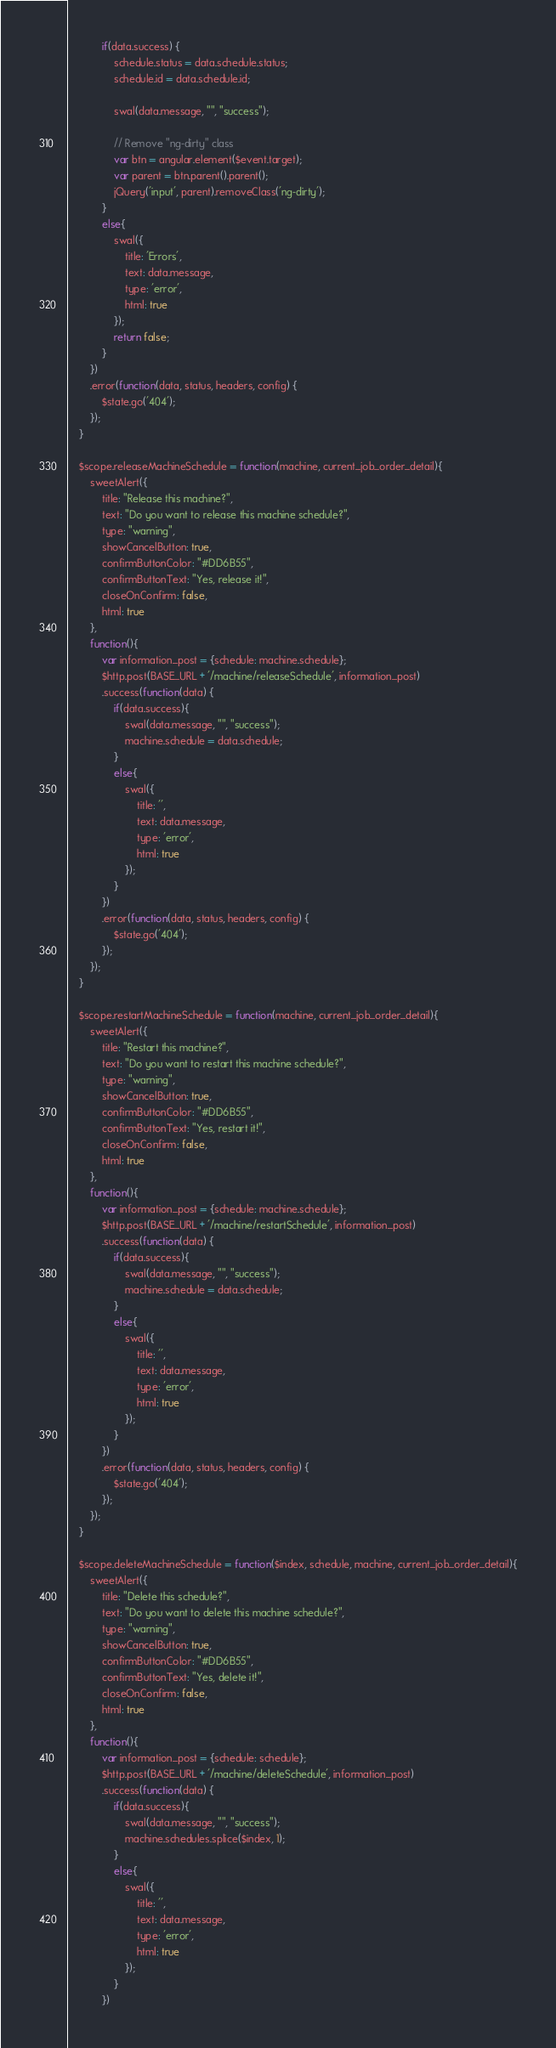Convert code to text. <code><loc_0><loc_0><loc_500><loc_500><_JavaScript_>		    if(data.success) {
		    	schedule.status = data.schedule.status;
		    	schedule.id = data.schedule.id;

		    	swal(data.message, "", "success");

		    	// Remove "ng-dirty" class
		    	var btn = angular.element($event.target);
		    	var parent = btn.parent().parent();
		    	jQuery('input', parent).removeClass('ng-dirty');
		    }
		    else{
		    	swal({
		    		title: 'Errors',
		    		text: data.message,
		    		type: 'error',
		    		html: true
		    	});
		    	return false;
		    }
		})
		.error(function(data, status, headers, config) {
    		$state.go('404');	
  		});
	}

	$scope.releaseMachineSchedule = function(machine, current_job_order_detail){
		sweetAlert({
			title: "Release this machine?",
	      	text: "Do you want to release this machine schedule?",
	      	type: "warning",
	      	showCancelButton: true,
	      	confirmButtonColor: "#DD6B55",
	      	confirmButtonText: "Yes, release it!",
	      	closeOnConfirm: false,
	      	html: true
	    },
	    function(){
			var information_post = {schedule: machine.schedule};
			$http.post(BASE_URL + '/machine/releaseSchedule', information_post)
		    .success(function(data) {
			    if(data.success){
			    	swal(data.message, "", "success");
	                machine.schedule = data.schedule;
			    }
			    else{
			    	swal({
			    		title: '',
			    		text: data.message,
			    		type: 'error',
			    		html: true
			    	});
			    }
			})
			.error(function(data, status, headers, config) {
	    		$state.go('404');	
	  		});
	    });
	}

	$scope.restartMachineSchedule = function(machine, current_job_order_detail){
		sweetAlert({
			title: "Restart this machine?",
	      	text: "Do you want to restart this machine schedule?",
	      	type: "warning",
	      	showCancelButton: true,
	      	confirmButtonColor: "#DD6B55",
	      	confirmButtonText: "Yes, restart it!",
	      	closeOnConfirm: false,
	      	html: true
	    },
	    function(){
			var information_post = {schedule: machine.schedule};
			$http.post(BASE_URL + '/machine/restartSchedule', information_post)
		    .success(function(data) {
			    if(data.success){
			    	swal(data.message, "", "success");
	                machine.schedule = data.schedule;
			    }
			    else{
			    	swal({
			    		title: '',
			    		text: data.message,
			    		type: 'error',
			    		html: true
			    	});
			    }
			})
			.error(function(data, status, headers, config) {
	    		$state.go('404');	
	  		});
	    });
	}

	$scope.deleteMachineSchedule = function($index, schedule, machine, current_job_order_detail){
		sweetAlert({
			title: "Delete this schedule?",
	      	text: "Do you want to delete this machine schedule?",
	      	type: "warning",
	      	showCancelButton: true,
	      	confirmButtonColor: "#DD6B55",
	      	confirmButtonText: "Yes, delete it!",
	      	closeOnConfirm: false,
	      	html: true
	    },
	    function(){
			var information_post = {schedule: schedule};
			$http.post(BASE_URL + '/machine/deleteSchedule', information_post)
		    .success(function(data) {
			    if(data.success){
			    	swal(data.message, "", "success");
	                machine.schedules.splice($index, 1);
			    }
			    else{
			    	swal({
			    		title: '',
			    		text: data.message,
			    		type: 'error',
			    		html: true
			    	});
			    }
			})</code> 